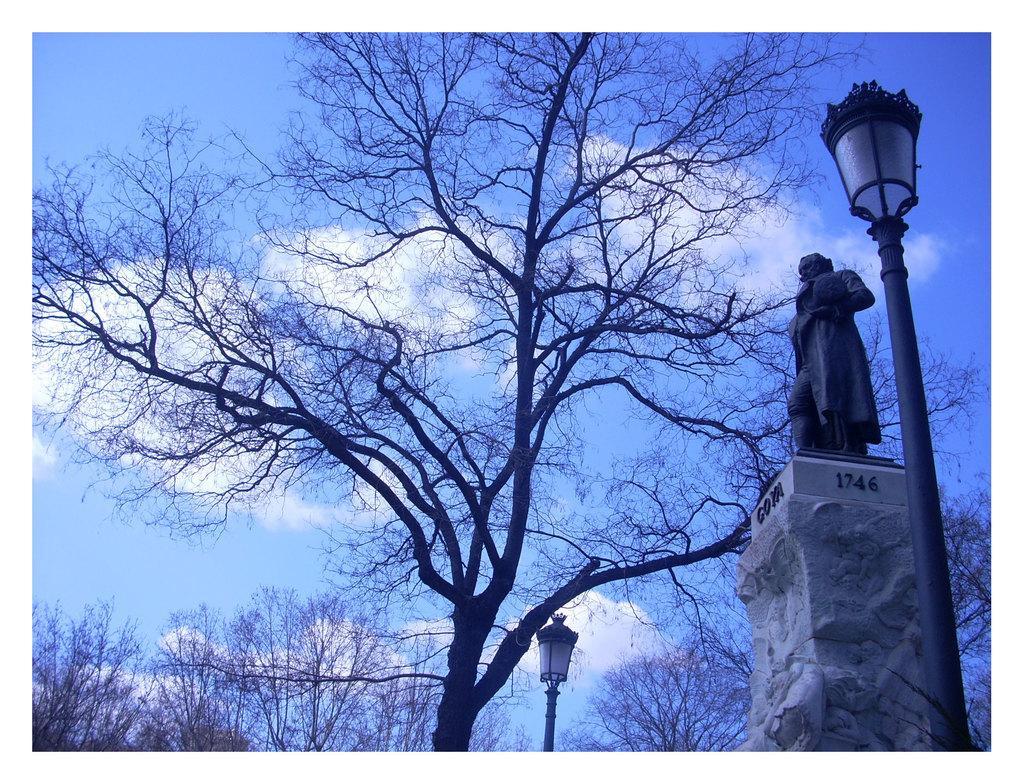How would you summarize this image in a sentence or two? In this image, there are a few trees. We can see some poles with lights. We can also see a statue on a pillar with some text. We can see the sky with clouds. 